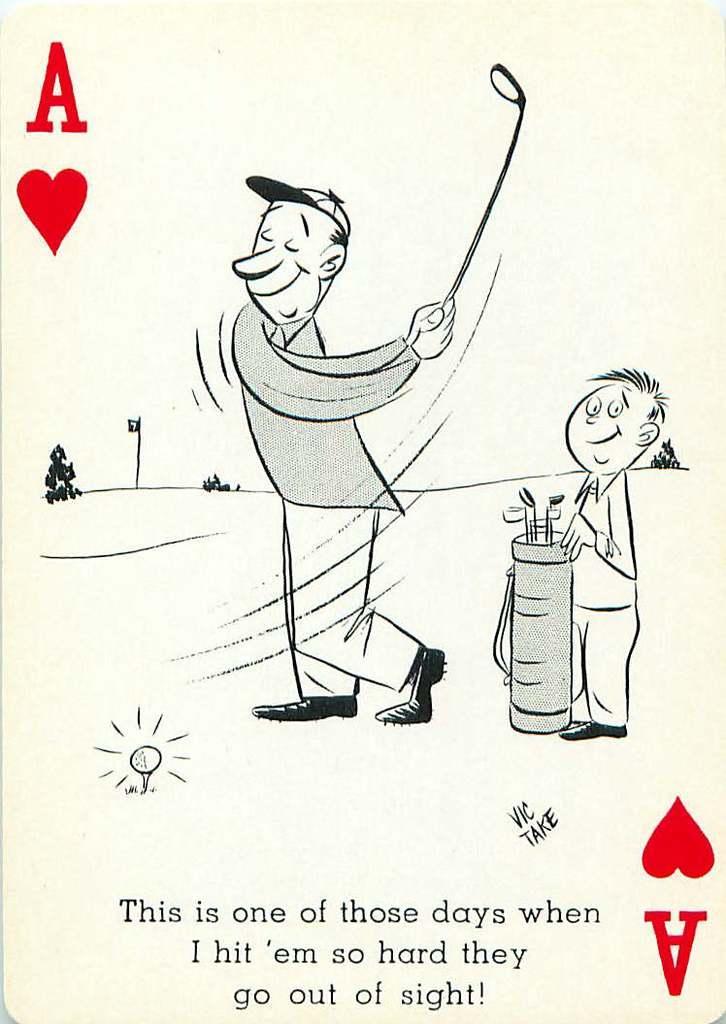Could you give a brief overview of what you see in this image? This image consists of a playing card. On which there is a picture of a man and a boy. At the bottom, there is a text. 